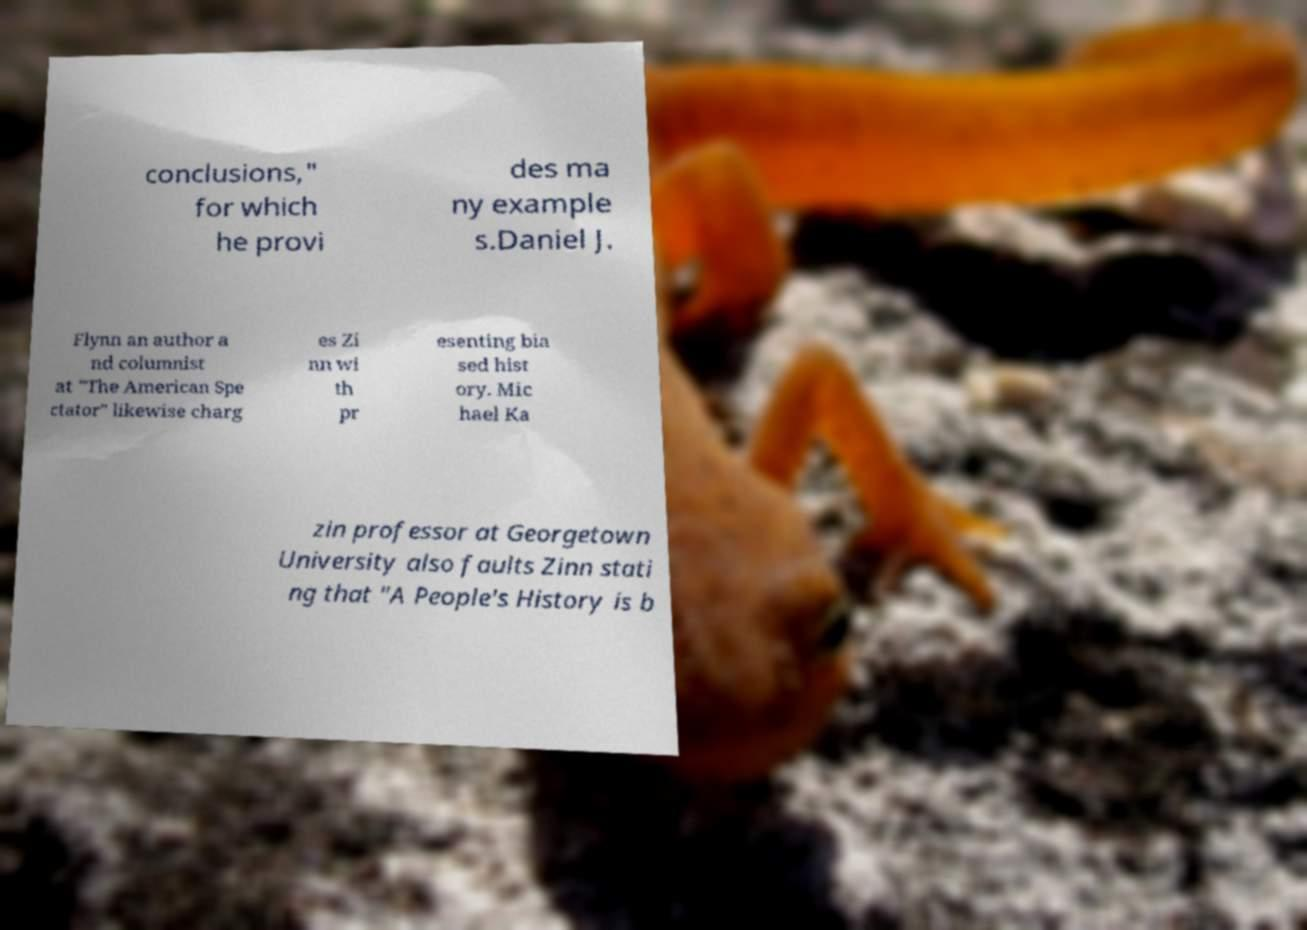I need the written content from this picture converted into text. Can you do that? conclusions," for which he provi des ma ny example s.Daniel J. Flynn an author a nd columnist at "The American Spe ctator" likewise charg es Zi nn wi th pr esenting bia sed hist ory. Mic hael Ka zin professor at Georgetown University also faults Zinn stati ng that "A People's History is b 